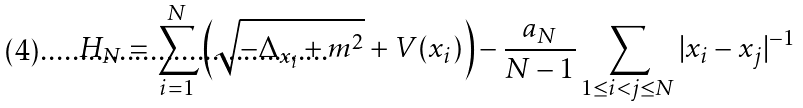<formula> <loc_0><loc_0><loc_500><loc_500>H _ { N } = \sum _ { i = 1 } ^ { N } \left ( \sqrt { - \Delta _ { x _ { i } } + m ^ { 2 } } + V ( x _ { i } ) \right ) - \frac { a _ { N } } { N - 1 } \sum _ { 1 \leq i < j \leq N } | x _ { i } - x _ { j } | ^ { - 1 }</formula> 